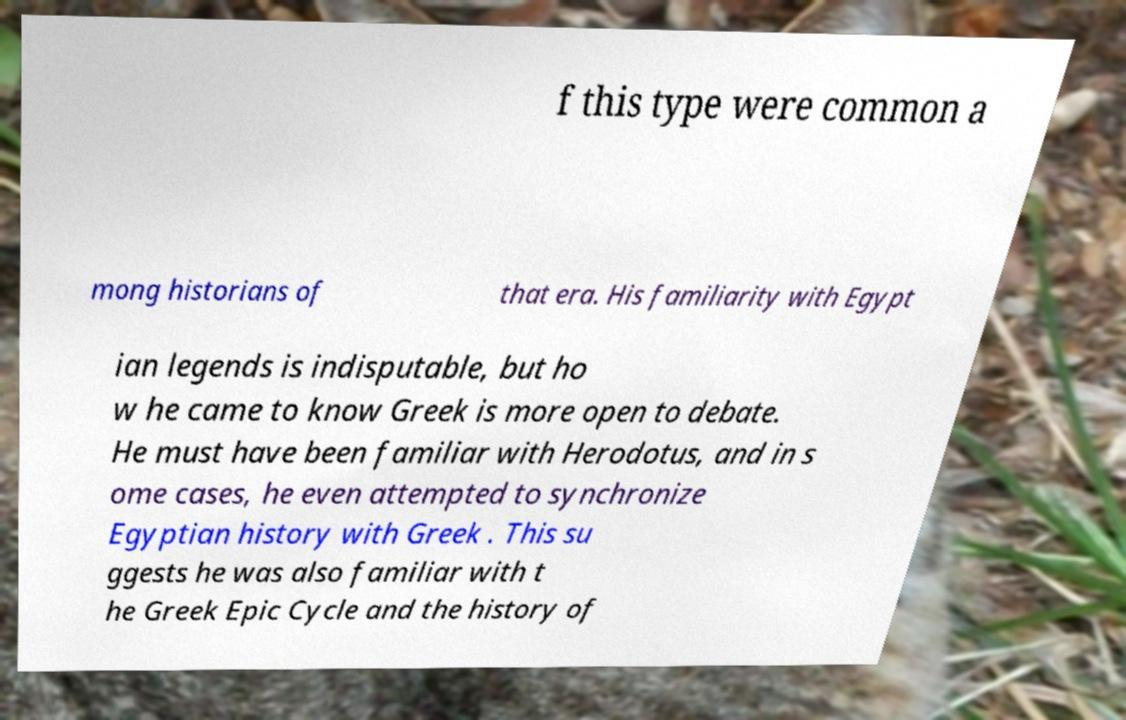Please identify and transcribe the text found in this image. f this type were common a mong historians of that era. His familiarity with Egypt ian legends is indisputable, but ho w he came to know Greek is more open to debate. He must have been familiar with Herodotus, and in s ome cases, he even attempted to synchronize Egyptian history with Greek . This su ggests he was also familiar with t he Greek Epic Cycle and the history of 